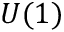<formula> <loc_0><loc_0><loc_500><loc_500>U ( 1 )</formula> 